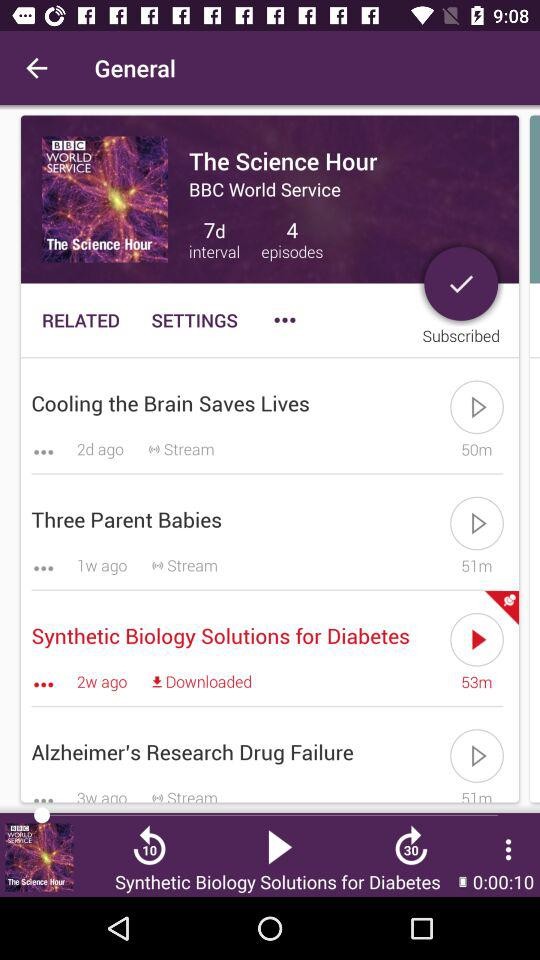How many days ago was the Cooling the Brain Saves Lives episode updated?
When the provided information is insufficient, respond with <no answer>. <no answer> 